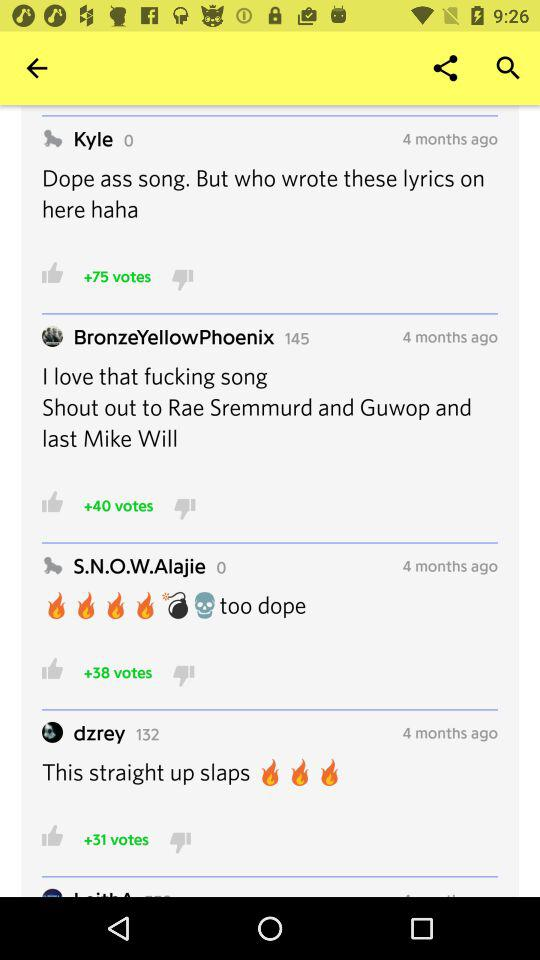How many months ago did "S.N.O.W.Alajie" post the comment? "S.N.O.W.Alajie" posted the comment 4 months ago. 